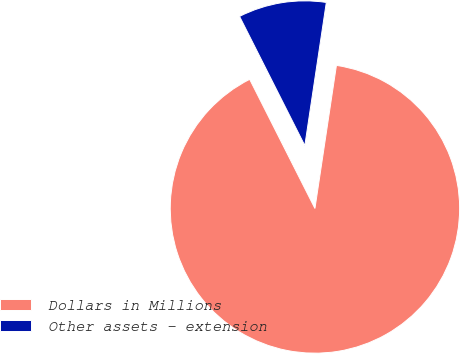<chart> <loc_0><loc_0><loc_500><loc_500><pie_chart><fcel>Dollars in Millions<fcel>Other assets - extension<nl><fcel>90.18%<fcel>9.82%<nl></chart> 